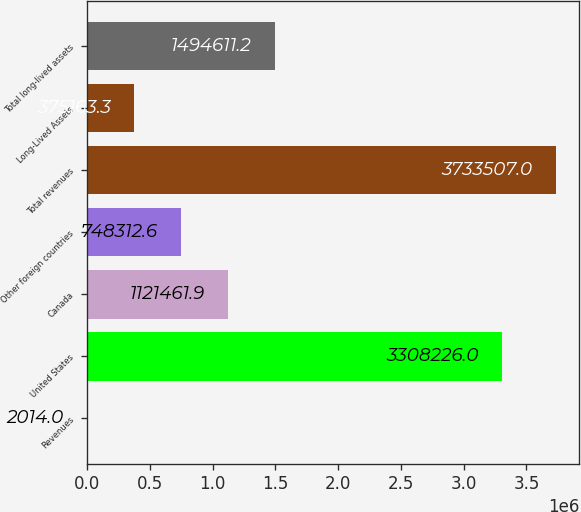Convert chart. <chart><loc_0><loc_0><loc_500><loc_500><bar_chart><fcel>Revenues<fcel>United States<fcel>Canada<fcel>Other foreign countries<fcel>Total revenues<fcel>Long-Lived Assets<fcel>Total long-lived assets<nl><fcel>2014<fcel>3.30823e+06<fcel>1.12146e+06<fcel>748313<fcel>3.73351e+06<fcel>375163<fcel>1.49461e+06<nl></chart> 